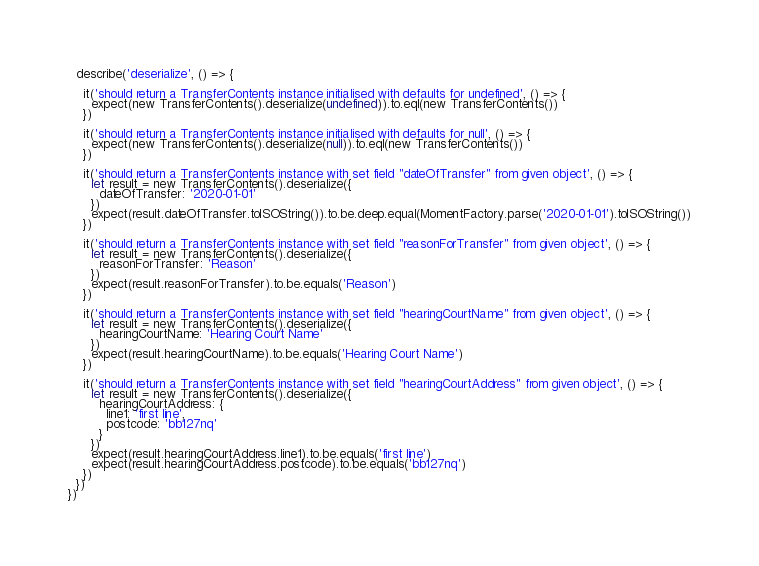Convert code to text. <code><loc_0><loc_0><loc_500><loc_500><_TypeScript_>  describe('deserialize', () => {

    it('should return a TransferContents instance initialised with defaults for undefined', () => {
      expect(new TransferContents().deserialize(undefined)).to.eql(new TransferContents())
    })

    it('should return a TransferContents instance initialised with defaults for null', () => {
      expect(new TransferContents().deserialize(null)).to.eql(new TransferContents())
    })

    it('should return a TransferContents instance with set field "dateOfTransfer" from given object', () => {
      let result = new TransferContents().deserialize({
        dateOfTransfer: '2020-01-01'
      })
      expect(result.dateOfTransfer.toISOString()).to.be.deep.equal(MomentFactory.parse('2020-01-01').toISOString())
    })

    it('should return a TransferContents instance with set field "reasonForTransfer" from given object', () => {
      let result = new TransferContents().deserialize({
        reasonForTransfer: 'Reason'
      })
      expect(result.reasonForTransfer).to.be.equals('Reason')
    })

    it('should return a TransferContents instance with set field "hearingCourtName" from given object', () => {
      let result = new TransferContents().deserialize({
        hearingCourtName: 'Hearing Court Name'
      })
      expect(result.hearingCourtName).to.be.equals('Hearing Court Name')
    })

    it('should return a TransferContents instance with set field "hearingCourtAddress" from given object', () => {
      let result = new TransferContents().deserialize({
        hearingCourtAddress: {
          line1: 'first line',
          postcode: 'bb127nq'
        }
      })
      expect(result.hearingCourtAddress.line1).to.be.equals('first line')
      expect(result.hearingCourtAddress.postcode).to.be.equals('bb127nq')
    })
  })
})
</code> 